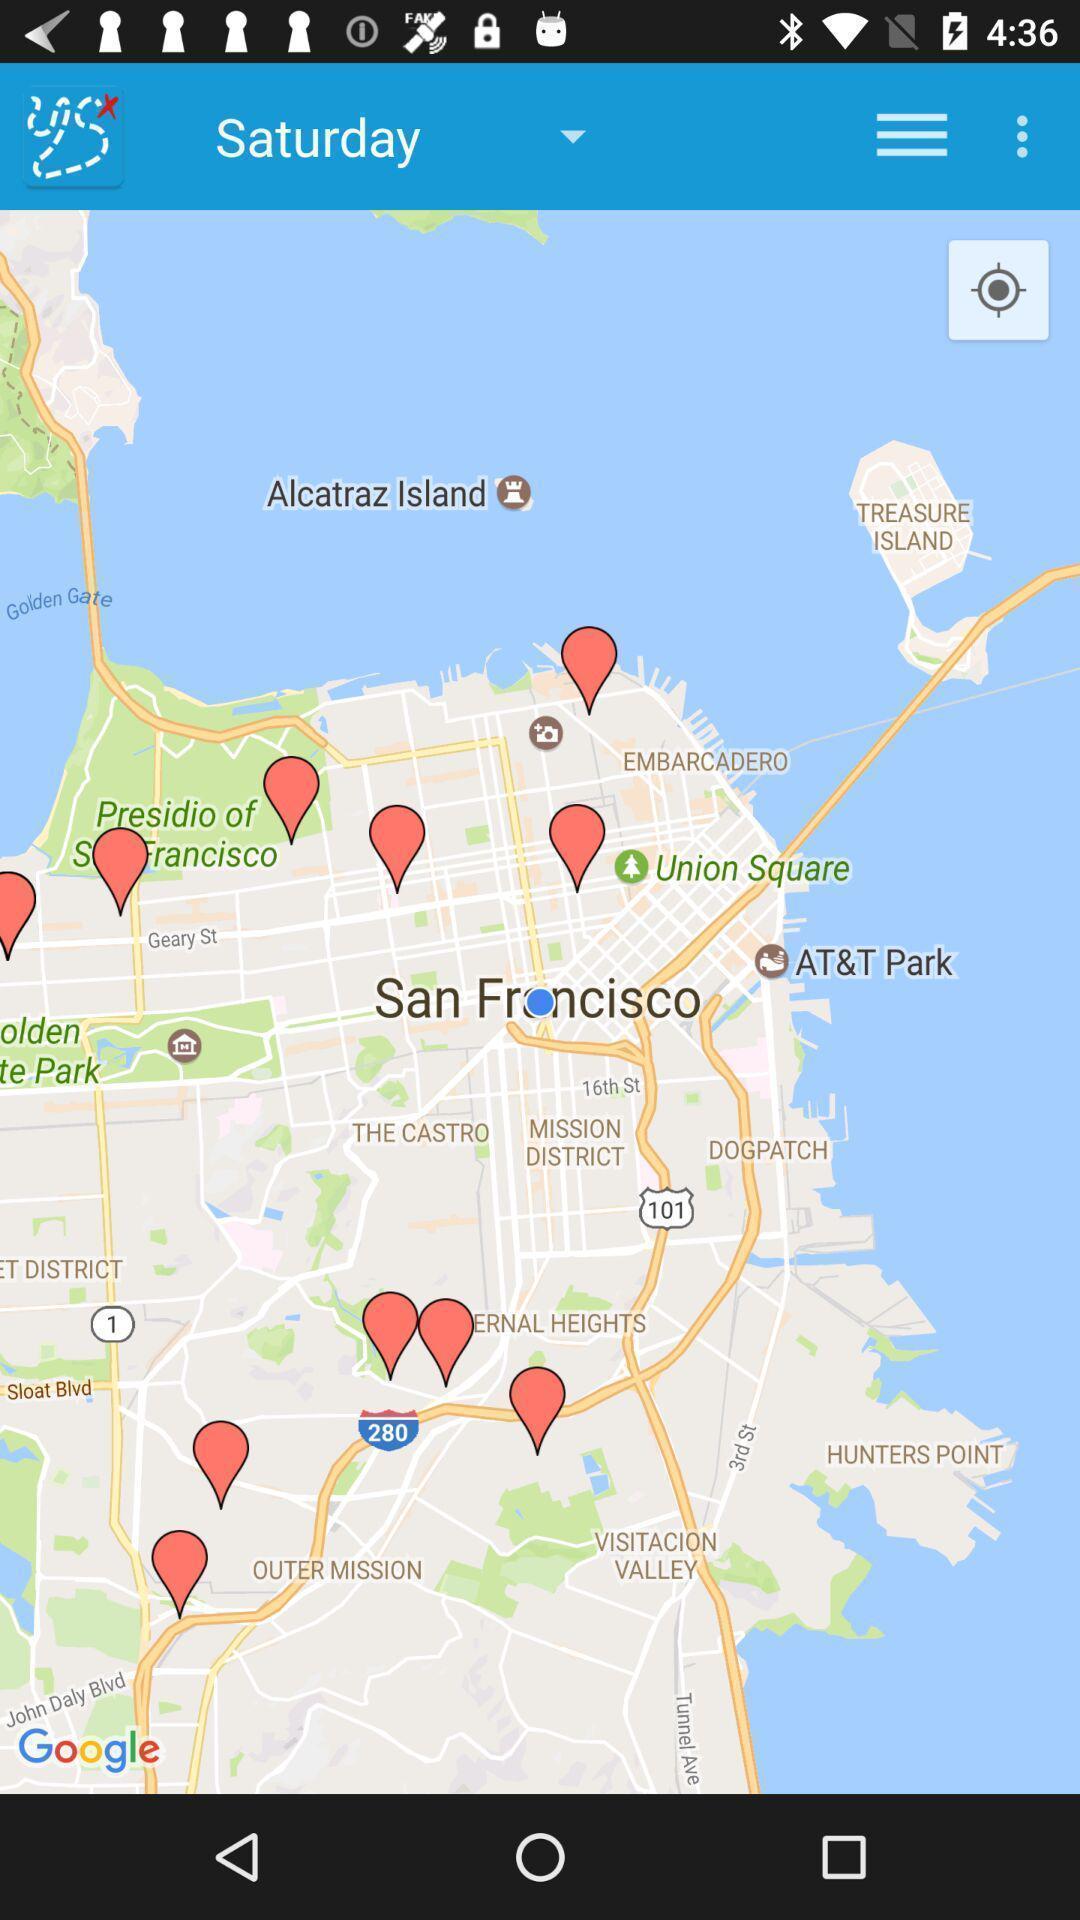Please provide a description for this image. Page displaying for route finder app. 